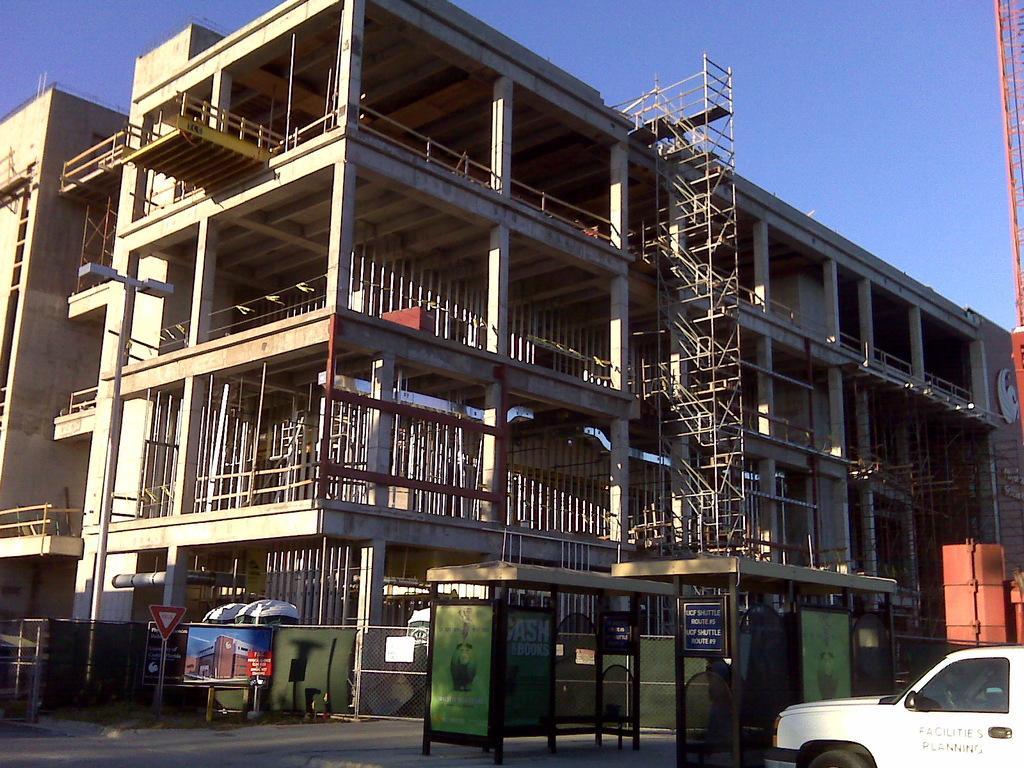Describe this image in one or two sentences. In this picture we can see the buildings, rods. At the bottom of the image we can see the boards, shed, grilles, road, vehicle. On the right side of the image we can see a crane. At the top of the image we can see the sky. 